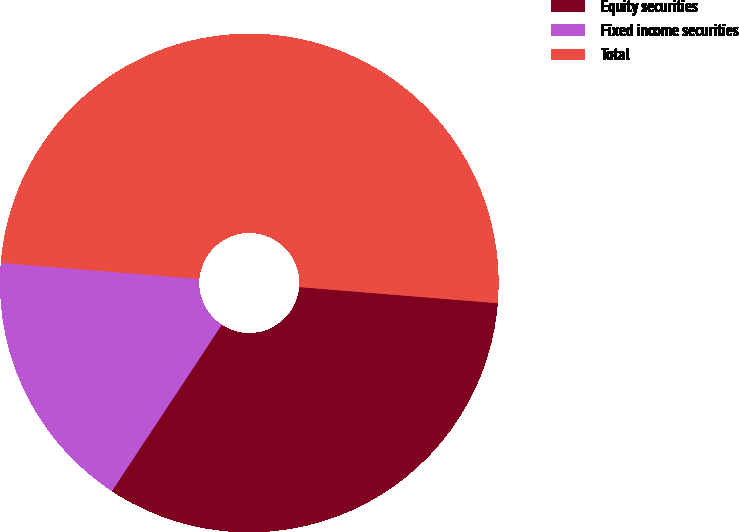<chart> <loc_0><loc_0><loc_500><loc_500><pie_chart><fcel>Equity securities<fcel>Fixed income securities<fcel>Total<nl><fcel>33.0%<fcel>17.0%<fcel>50.0%<nl></chart> 